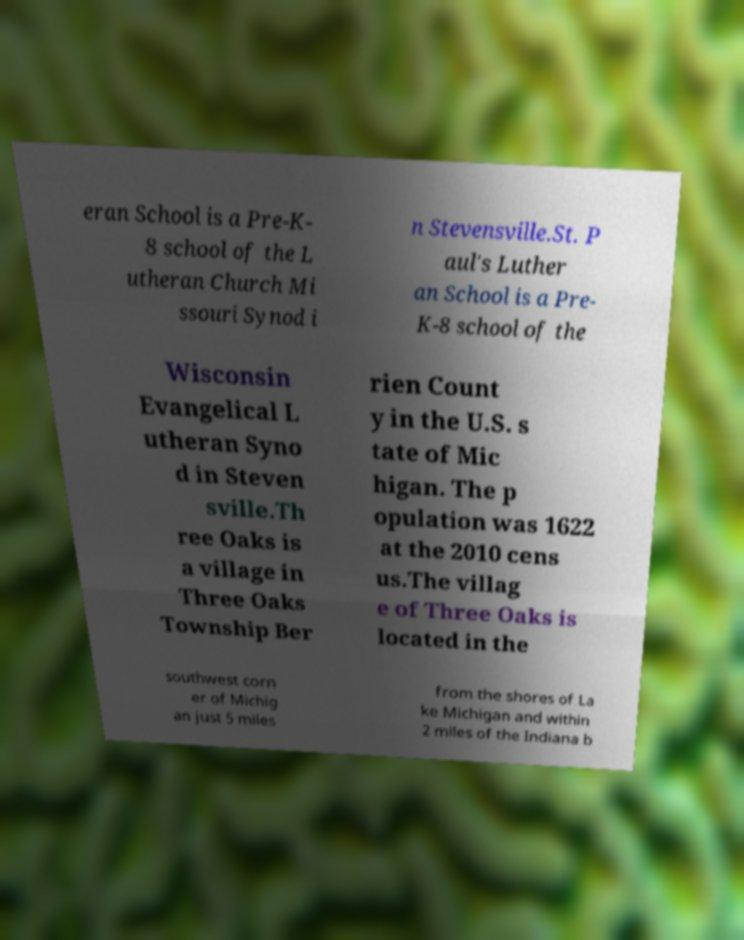Can you accurately transcribe the text from the provided image for me? eran School is a Pre-K- 8 school of the L utheran Church Mi ssouri Synod i n Stevensville.St. P aul's Luther an School is a Pre- K-8 school of the Wisconsin Evangelical L utheran Syno d in Steven sville.Th ree Oaks is a village in Three Oaks Township Ber rien Count y in the U.S. s tate of Mic higan. The p opulation was 1622 at the 2010 cens us.The villag e of Three Oaks is located in the southwest corn er of Michig an just 5 miles from the shores of La ke Michigan and within 2 miles of the Indiana b 